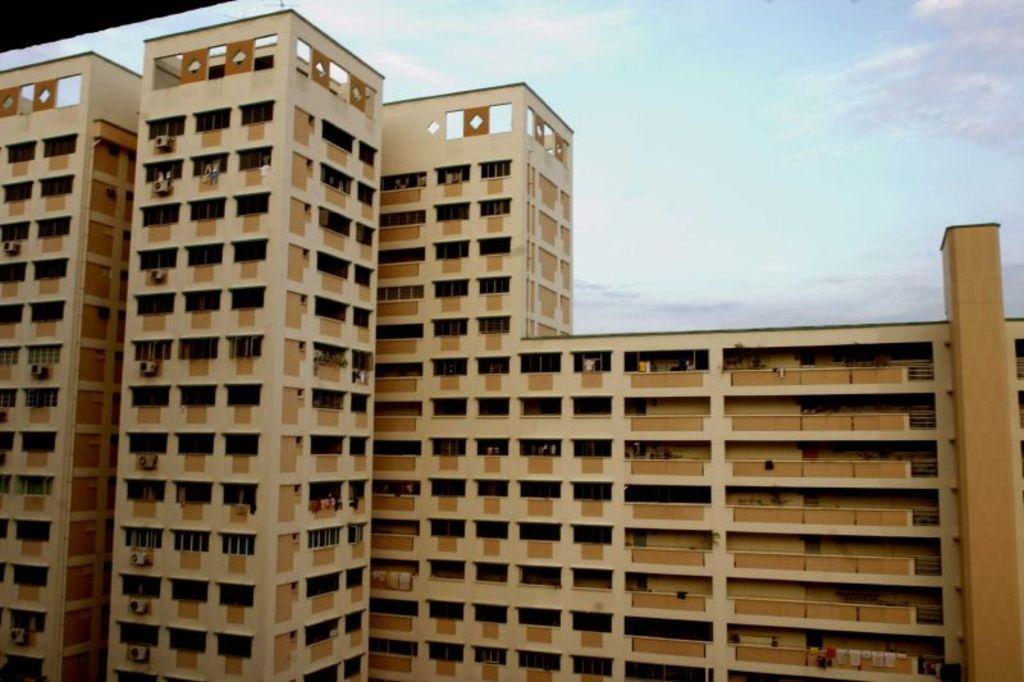Describe this image in one or two sentences. In this image I can see the building which is in brown color. In the back I can see the clouds and the blue sky. 